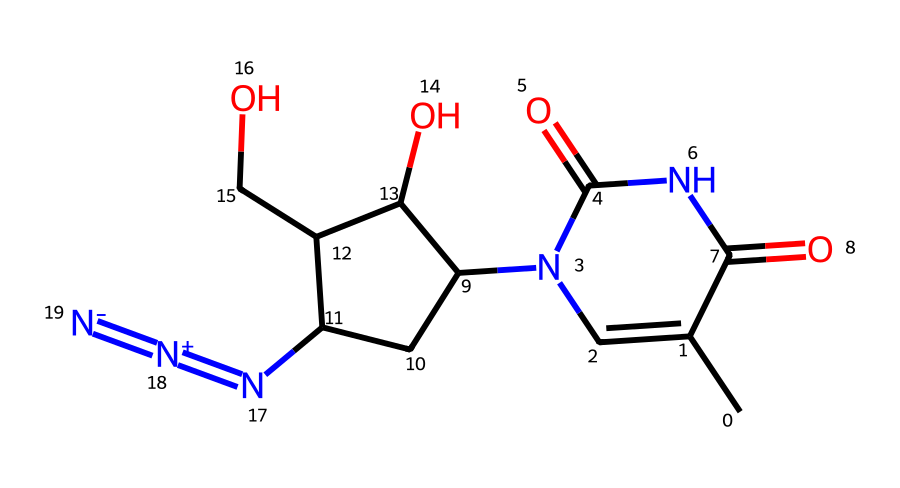What is the molecular formula of azidothymidine? The chemical structure can be analyzed to determine the number of each type of atom present. Counting the atoms reveals that there are 10 carbon atoms (C), 13 hydrogen atoms (H), 5 nitrogen atoms (N), and 4 oxygen atoms (O), leading to the molecular formula C10H13N5O4.
Answer: C10H13N5O4 How many nitrogen atoms are present in azidothymidine? By inspecting the chemical structure, we can identify the nitrogen atoms. There are five nitrogen atoms easily identifiable in the SMILES representation, specifically in the azide functional group and the amine groups.
Answer: 5 What type of functional group is present in azidothymidine? The presence of the -N=N+N- in the chemical structure indicates that there is an azide functional group. This can be recognized by the distinct arrangement of nitrogen atoms.
Answer: azide How many rings are present in the structure of azidothymidine? The chemical structure includes a cyclic component (the pyrimidine ring and a second cycle within the sugar moiety) which can be inspected to establish the ring count. There are two rings in total.
Answer: 2 What role does the azide group play in the pharmacological activity of azidothymidine? The azide group is crucial for AZT's mechanism of action as it is involved in the inhibition of reverse transcriptase, a key enzyme in HIV replication. The presence of this group allows AZT to be incorporated into viral DNA, disrupting the replication process.
Answer: inhibition of reverse transcriptase What is the significance of the hydroxyl group in azidothymidine? The hydroxyl (-OH) group in the structure contributes to the drug's solubility and biological characteristics. It allows for hydrogen bonding, which can affect the interaction of AZT with enzymes and its transport in biological systems.
Answer: solubility and interaction 